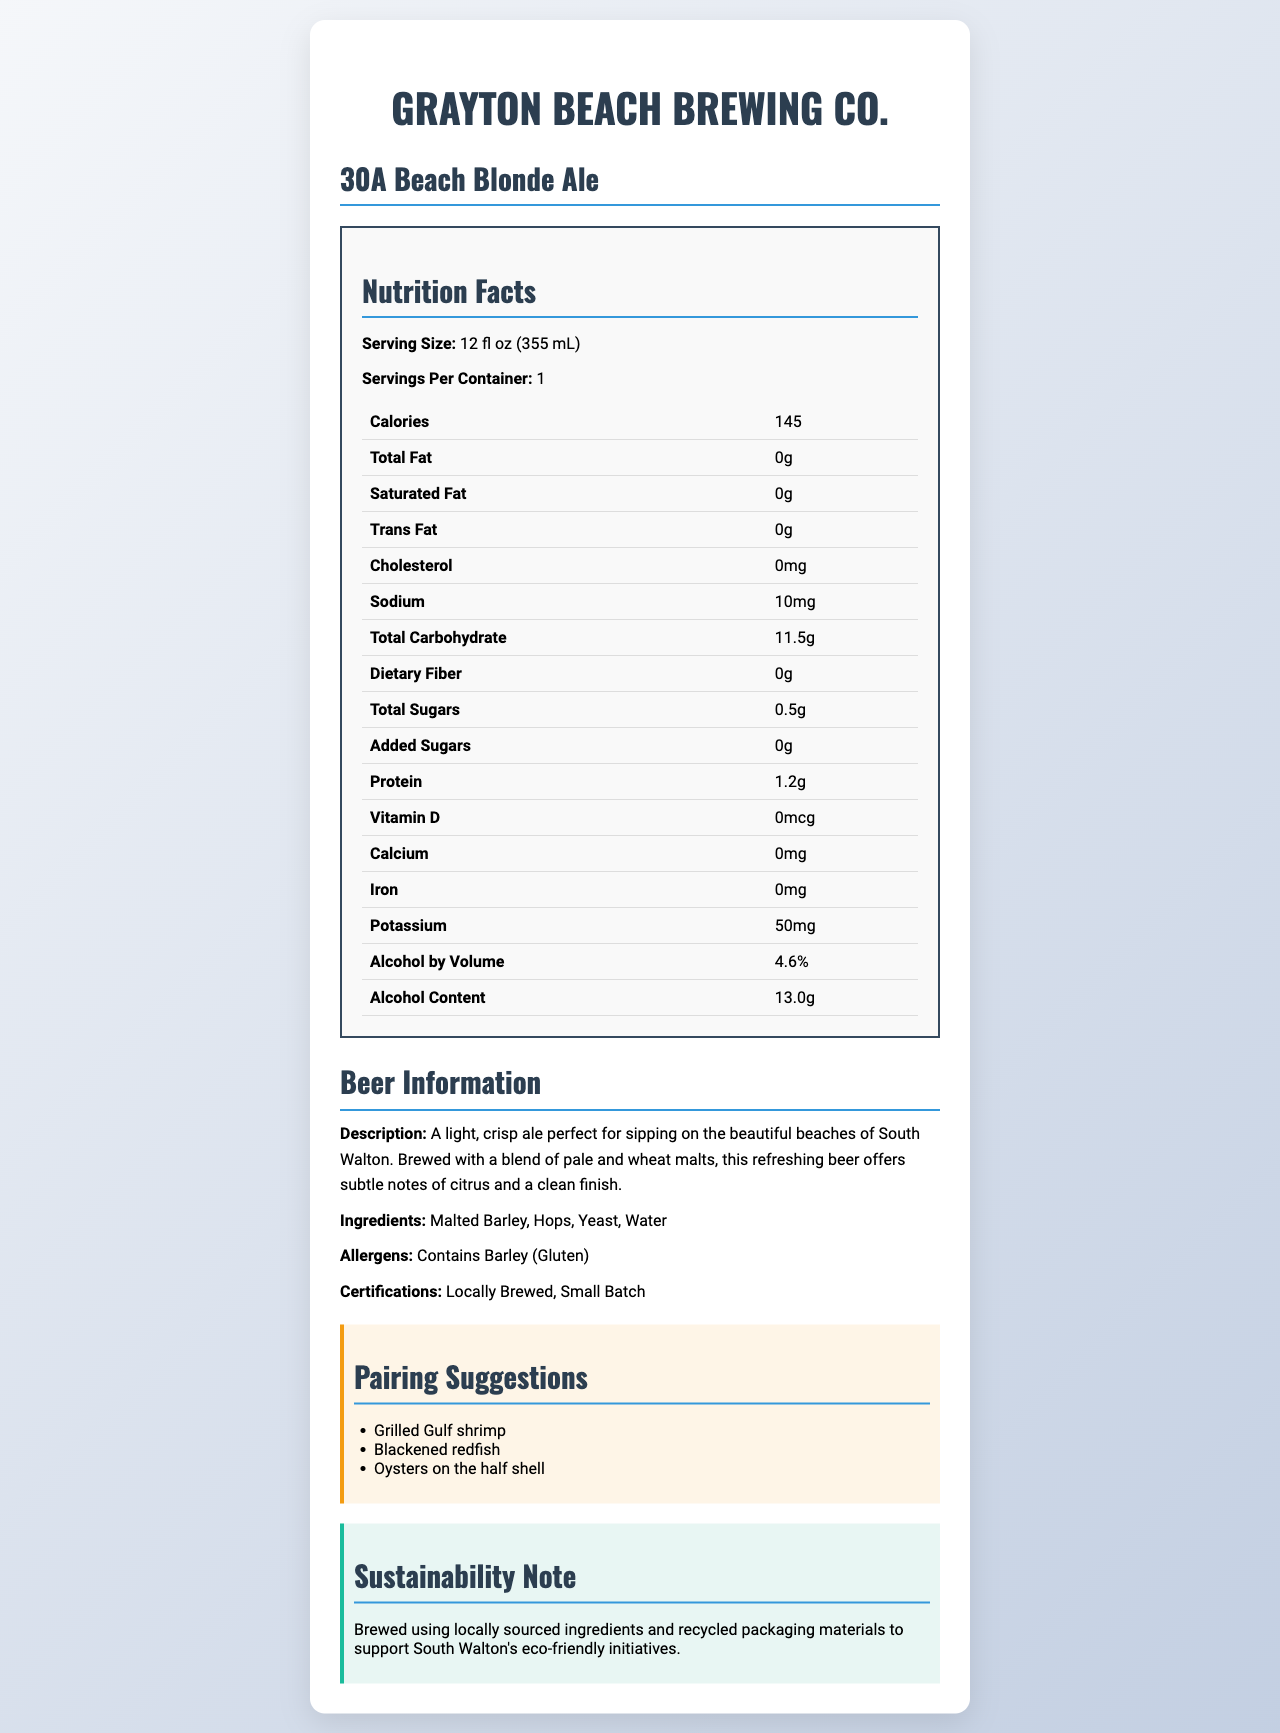what is the serving size for the 30A Beach Blonde Ale? The document states that the serving size for the 30A Beach Blonde Ale is 12 fl oz (355 mL).
Answer: 12 fl oz (355 mL) how many grams of total carbohydrates are in one serving of this beer? The document indicates that the beer contains 11.5 grams of total carbohydrates per serving.
Answer: 11.5 grams what is the alcohol by volume (ABV) percentage of the 30A Beach Blonde Ale? The document lists the alcohol by volume percentage as 4.6%.
Answer: 4.6% how much sodium is in one serving of the beer? The document shows that the beer contains 10 mg of sodium per serving.
Answer: 10 mg does the nutrition label state the amount of added sugars? The document specifies that added sugars amount to 0 grams.
Answer: Yes what is the main purpose of the sustainability note in the document? The document includes a sustainability note which highlights that the beer is brewed using locally sourced ingredients and recycled packaging materials.
Answer: To inform readers about the brewery's efforts to use locally sourced ingredients and recycled packaging materials to support eco-friendly initiatives in South Walton. which ingredient in the beer might be an allergen? A. Malted Barley B. Hops C. Yeast D. Water The document mentions that the beer contains barley, which is a known gluten allergen.
Answer: A. Malted Barley how many calories are in a 12 fl oz serving of the 30A Beach Blonde Ale? A. 100 B. 120 C. 145 D. 160 The document lists 145 calories per 12 fl oz serving.
Answer: C. 145 is this beer suitable for someone who is trying to avoid added sugars? The document indicates that the beer has 0 grams of added sugars.
Answer: Yes summarize the overall content and purpose of the document. The document serves as a comprehensive source of information on the beer, listing its macronutrient content, alcohol content, ingredients, allergens, certifications, pairing suggestions, description, and sustainability note.
Answer: The document provides detailed information about the 30A Beach Blonde Ale from Grayton Beach Brewing Co., including its nutritional facts, ingredients, allergens, pairing suggestions, and sustainability practices. It aims to inform consumers about the beer's health-related attributes, ingredients, and suggested food pairings, while also highlighting the brewery's commitment to eco-friendly practices. how many grams of dietary fiber does one serving of the beer contain? According to the document, the beer contains 0 grams of dietary fiber in each serving.
Answer: 0 grams which of the following is a certification for this beer? A. Organic B. Small Batch C. Gluten-Free The document certifies that the beer is Small Batch and also mentions that it is locally brewed.
Answer: B. Small Batch how many grams of protein are in one serving of the 30A Beach Blonde Ale? The document states that there are 1.2 grams of protein in one serving of the beer.
Answer: 1.2 grams is this document sufficient to determine if the beer is low in calories compared to other beers? The document provides the calorie content for the 30A Beach Blonde Ale, but does not provide context or comparison to the calorie content of other beers.
Answer: No, I don't know how much potassium is in one serving of the beer? The document lists the potassium content as 50 mg per serving.
Answer: 50 mg 